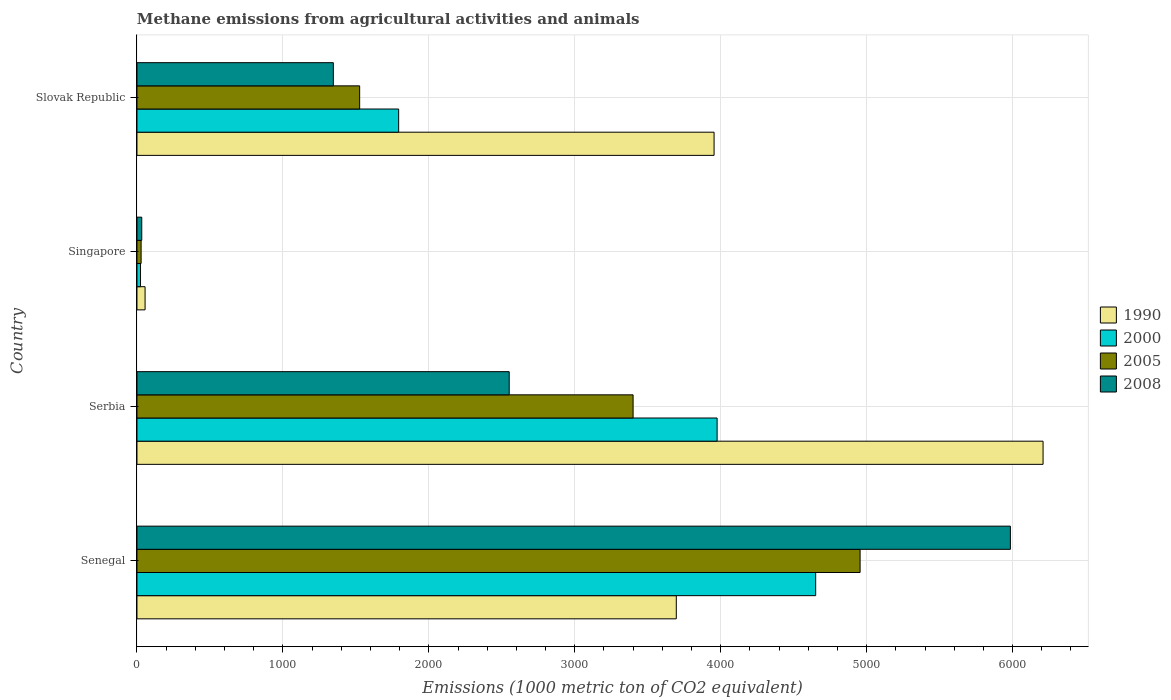How many different coloured bars are there?
Ensure brevity in your answer.  4. How many bars are there on the 3rd tick from the top?
Your answer should be compact. 4. What is the label of the 4th group of bars from the top?
Provide a short and direct response. Senegal. What is the amount of methane emitted in 2005 in Slovak Republic?
Ensure brevity in your answer.  1525.9. Across all countries, what is the maximum amount of methane emitted in 2005?
Make the answer very short. 4955.1. Across all countries, what is the minimum amount of methane emitted in 2008?
Offer a very short reply. 32.8. In which country was the amount of methane emitted in 2005 maximum?
Provide a succinct answer. Senegal. In which country was the amount of methane emitted in 1990 minimum?
Offer a terse response. Singapore. What is the total amount of methane emitted in 2005 in the graph?
Your answer should be very brief. 9909. What is the difference between the amount of methane emitted in 2005 in Senegal and that in Serbia?
Make the answer very short. 1555.5. What is the difference between the amount of methane emitted in 2008 in Serbia and the amount of methane emitted in 2005 in Slovak Republic?
Your response must be concise. 1024.8. What is the average amount of methane emitted in 2005 per country?
Provide a succinct answer. 2477.25. What is the difference between the amount of methane emitted in 1990 and amount of methane emitted in 2000 in Slovak Republic?
Provide a succinct answer. 2161.3. In how many countries, is the amount of methane emitted in 2008 greater than 2000 1000 metric ton?
Ensure brevity in your answer.  2. What is the ratio of the amount of methane emitted in 2000 in Senegal to that in Singapore?
Your response must be concise. 190.6. Is the amount of methane emitted in 2008 in Senegal less than that in Slovak Republic?
Offer a terse response. No. What is the difference between the highest and the second highest amount of methane emitted in 2000?
Offer a very short reply. 675.4. What is the difference between the highest and the lowest amount of methane emitted in 2008?
Offer a very short reply. 5952.1. In how many countries, is the amount of methane emitted in 2000 greater than the average amount of methane emitted in 2000 taken over all countries?
Your response must be concise. 2. Is it the case that in every country, the sum of the amount of methane emitted in 2000 and amount of methane emitted in 2008 is greater than the sum of amount of methane emitted in 1990 and amount of methane emitted in 2005?
Give a very brief answer. No. What does the 4th bar from the top in Senegal represents?
Offer a very short reply. 1990. What does the 3rd bar from the bottom in Singapore represents?
Provide a succinct answer. 2005. How many bars are there?
Provide a succinct answer. 16. What is the difference between two consecutive major ticks on the X-axis?
Your answer should be compact. 1000. Does the graph contain any zero values?
Offer a terse response. No. Does the graph contain grids?
Provide a succinct answer. Yes. Where does the legend appear in the graph?
Offer a terse response. Center right. How many legend labels are there?
Your response must be concise. 4. How are the legend labels stacked?
Ensure brevity in your answer.  Vertical. What is the title of the graph?
Provide a short and direct response. Methane emissions from agricultural activities and animals. What is the label or title of the X-axis?
Keep it short and to the point. Emissions (1000 metric ton of CO2 equivalent). What is the label or title of the Y-axis?
Your answer should be compact. Country. What is the Emissions (1000 metric ton of CO2 equivalent) of 1990 in Senegal?
Provide a succinct answer. 3695.6. What is the Emissions (1000 metric ton of CO2 equivalent) of 2000 in Senegal?
Provide a succinct answer. 4650.7. What is the Emissions (1000 metric ton of CO2 equivalent) in 2005 in Senegal?
Provide a succinct answer. 4955.1. What is the Emissions (1000 metric ton of CO2 equivalent) in 2008 in Senegal?
Ensure brevity in your answer.  5984.9. What is the Emissions (1000 metric ton of CO2 equivalent) in 1990 in Serbia?
Make the answer very short. 6208.8. What is the Emissions (1000 metric ton of CO2 equivalent) of 2000 in Serbia?
Give a very brief answer. 3975.3. What is the Emissions (1000 metric ton of CO2 equivalent) in 2005 in Serbia?
Offer a very short reply. 3399.6. What is the Emissions (1000 metric ton of CO2 equivalent) in 2008 in Serbia?
Your answer should be compact. 2550.7. What is the Emissions (1000 metric ton of CO2 equivalent) of 1990 in Singapore?
Offer a very short reply. 55.6. What is the Emissions (1000 metric ton of CO2 equivalent) in 2000 in Singapore?
Provide a succinct answer. 24.4. What is the Emissions (1000 metric ton of CO2 equivalent) of 2005 in Singapore?
Provide a short and direct response. 28.4. What is the Emissions (1000 metric ton of CO2 equivalent) in 2008 in Singapore?
Your answer should be very brief. 32.8. What is the Emissions (1000 metric ton of CO2 equivalent) of 1990 in Slovak Republic?
Your response must be concise. 3954.5. What is the Emissions (1000 metric ton of CO2 equivalent) of 2000 in Slovak Republic?
Provide a succinct answer. 1793.2. What is the Emissions (1000 metric ton of CO2 equivalent) in 2005 in Slovak Republic?
Provide a succinct answer. 1525.9. What is the Emissions (1000 metric ton of CO2 equivalent) in 2008 in Slovak Republic?
Offer a terse response. 1345.7. Across all countries, what is the maximum Emissions (1000 metric ton of CO2 equivalent) in 1990?
Offer a terse response. 6208.8. Across all countries, what is the maximum Emissions (1000 metric ton of CO2 equivalent) of 2000?
Provide a short and direct response. 4650.7. Across all countries, what is the maximum Emissions (1000 metric ton of CO2 equivalent) of 2005?
Offer a terse response. 4955.1. Across all countries, what is the maximum Emissions (1000 metric ton of CO2 equivalent) in 2008?
Offer a very short reply. 5984.9. Across all countries, what is the minimum Emissions (1000 metric ton of CO2 equivalent) of 1990?
Offer a very short reply. 55.6. Across all countries, what is the minimum Emissions (1000 metric ton of CO2 equivalent) in 2000?
Your answer should be very brief. 24.4. Across all countries, what is the minimum Emissions (1000 metric ton of CO2 equivalent) in 2005?
Offer a terse response. 28.4. Across all countries, what is the minimum Emissions (1000 metric ton of CO2 equivalent) in 2008?
Offer a terse response. 32.8. What is the total Emissions (1000 metric ton of CO2 equivalent) of 1990 in the graph?
Provide a short and direct response. 1.39e+04. What is the total Emissions (1000 metric ton of CO2 equivalent) in 2000 in the graph?
Provide a short and direct response. 1.04e+04. What is the total Emissions (1000 metric ton of CO2 equivalent) in 2005 in the graph?
Your answer should be compact. 9909. What is the total Emissions (1000 metric ton of CO2 equivalent) of 2008 in the graph?
Make the answer very short. 9914.1. What is the difference between the Emissions (1000 metric ton of CO2 equivalent) in 1990 in Senegal and that in Serbia?
Make the answer very short. -2513.2. What is the difference between the Emissions (1000 metric ton of CO2 equivalent) in 2000 in Senegal and that in Serbia?
Your answer should be very brief. 675.4. What is the difference between the Emissions (1000 metric ton of CO2 equivalent) in 2005 in Senegal and that in Serbia?
Offer a very short reply. 1555.5. What is the difference between the Emissions (1000 metric ton of CO2 equivalent) in 2008 in Senegal and that in Serbia?
Offer a terse response. 3434.2. What is the difference between the Emissions (1000 metric ton of CO2 equivalent) in 1990 in Senegal and that in Singapore?
Make the answer very short. 3640. What is the difference between the Emissions (1000 metric ton of CO2 equivalent) in 2000 in Senegal and that in Singapore?
Ensure brevity in your answer.  4626.3. What is the difference between the Emissions (1000 metric ton of CO2 equivalent) of 2005 in Senegal and that in Singapore?
Your answer should be very brief. 4926.7. What is the difference between the Emissions (1000 metric ton of CO2 equivalent) of 2008 in Senegal and that in Singapore?
Provide a short and direct response. 5952.1. What is the difference between the Emissions (1000 metric ton of CO2 equivalent) of 1990 in Senegal and that in Slovak Republic?
Provide a succinct answer. -258.9. What is the difference between the Emissions (1000 metric ton of CO2 equivalent) in 2000 in Senegal and that in Slovak Republic?
Your response must be concise. 2857.5. What is the difference between the Emissions (1000 metric ton of CO2 equivalent) of 2005 in Senegal and that in Slovak Republic?
Ensure brevity in your answer.  3429.2. What is the difference between the Emissions (1000 metric ton of CO2 equivalent) of 2008 in Senegal and that in Slovak Republic?
Give a very brief answer. 4639.2. What is the difference between the Emissions (1000 metric ton of CO2 equivalent) in 1990 in Serbia and that in Singapore?
Your answer should be very brief. 6153.2. What is the difference between the Emissions (1000 metric ton of CO2 equivalent) in 2000 in Serbia and that in Singapore?
Provide a succinct answer. 3950.9. What is the difference between the Emissions (1000 metric ton of CO2 equivalent) of 2005 in Serbia and that in Singapore?
Keep it short and to the point. 3371.2. What is the difference between the Emissions (1000 metric ton of CO2 equivalent) of 2008 in Serbia and that in Singapore?
Give a very brief answer. 2517.9. What is the difference between the Emissions (1000 metric ton of CO2 equivalent) of 1990 in Serbia and that in Slovak Republic?
Make the answer very short. 2254.3. What is the difference between the Emissions (1000 metric ton of CO2 equivalent) in 2000 in Serbia and that in Slovak Republic?
Your answer should be very brief. 2182.1. What is the difference between the Emissions (1000 metric ton of CO2 equivalent) in 2005 in Serbia and that in Slovak Republic?
Offer a very short reply. 1873.7. What is the difference between the Emissions (1000 metric ton of CO2 equivalent) in 2008 in Serbia and that in Slovak Republic?
Provide a succinct answer. 1205. What is the difference between the Emissions (1000 metric ton of CO2 equivalent) in 1990 in Singapore and that in Slovak Republic?
Your answer should be compact. -3898.9. What is the difference between the Emissions (1000 metric ton of CO2 equivalent) in 2000 in Singapore and that in Slovak Republic?
Ensure brevity in your answer.  -1768.8. What is the difference between the Emissions (1000 metric ton of CO2 equivalent) in 2005 in Singapore and that in Slovak Republic?
Provide a succinct answer. -1497.5. What is the difference between the Emissions (1000 metric ton of CO2 equivalent) of 2008 in Singapore and that in Slovak Republic?
Your answer should be compact. -1312.9. What is the difference between the Emissions (1000 metric ton of CO2 equivalent) in 1990 in Senegal and the Emissions (1000 metric ton of CO2 equivalent) in 2000 in Serbia?
Ensure brevity in your answer.  -279.7. What is the difference between the Emissions (1000 metric ton of CO2 equivalent) of 1990 in Senegal and the Emissions (1000 metric ton of CO2 equivalent) of 2005 in Serbia?
Your response must be concise. 296. What is the difference between the Emissions (1000 metric ton of CO2 equivalent) of 1990 in Senegal and the Emissions (1000 metric ton of CO2 equivalent) of 2008 in Serbia?
Give a very brief answer. 1144.9. What is the difference between the Emissions (1000 metric ton of CO2 equivalent) in 2000 in Senegal and the Emissions (1000 metric ton of CO2 equivalent) in 2005 in Serbia?
Give a very brief answer. 1251.1. What is the difference between the Emissions (1000 metric ton of CO2 equivalent) of 2000 in Senegal and the Emissions (1000 metric ton of CO2 equivalent) of 2008 in Serbia?
Provide a short and direct response. 2100. What is the difference between the Emissions (1000 metric ton of CO2 equivalent) in 2005 in Senegal and the Emissions (1000 metric ton of CO2 equivalent) in 2008 in Serbia?
Ensure brevity in your answer.  2404.4. What is the difference between the Emissions (1000 metric ton of CO2 equivalent) of 1990 in Senegal and the Emissions (1000 metric ton of CO2 equivalent) of 2000 in Singapore?
Give a very brief answer. 3671.2. What is the difference between the Emissions (1000 metric ton of CO2 equivalent) in 1990 in Senegal and the Emissions (1000 metric ton of CO2 equivalent) in 2005 in Singapore?
Ensure brevity in your answer.  3667.2. What is the difference between the Emissions (1000 metric ton of CO2 equivalent) of 1990 in Senegal and the Emissions (1000 metric ton of CO2 equivalent) of 2008 in Singapore?
Give a very brief answer. 3662.8. What is the difference between the Emissions (1000 metric ton of CO2 equivalent) in 2000 in Senegal and the Emissions (1000 metric ton of CO2 equivalent) in 2005 in Singapore?
Offer a very short reply. 4622.3. What is the difference between the Emissions (1000 metric ton of CO2 equivalent) in 2000 in Senegal and the Emissions (1000 metric ton of CO2 equivalent) in 2008 in Singapore?
Offer a terse response. 4617.9. What is the difference between the Emissions (1000 metric ton of CO2 equivalent) in 2005 in Senegal and the Emissions (1000 metric ton of CO2 equivalent) in 2008 in Singapore?
Offer a very short reply. 4922.3. What is the difference between the Emissions (1000 metric ton of CO2 equivalent) of 1990 in Senegal and the Emissions (1000 metric ton of CO2 equivalent) of 2000 in Slovak Republic?
Your answer should be very brief. 1902.4. What is the difference between the Emissions (1000 metric ton of CO2 equivalent) in 1990 in Senegal and the Emissions (1000 metric ton of CO2 equivalent) in 2005 in Slovak Republic?
Your answer should be very brief. 2169.7. What is the difference between the Emissions (1000 metric ton of CO2 equivalent) of 1990 in Senegal and the Emissions (1000 metric ton of CO2 equivalent) of 2008 in Slovak Republic?
Your answer should be very brief. 2349.9. What is the difference between the Emissions (1000 metric ton of CO2 equivalent) of 2000 in Senegal and the Emissions (1000 metric ton of CO2 equivalent) of 2005 in Slovak Republic?
Offer a very short reply. 3124.8. What is the difference between the Emissions (1000 metric ton of CO2 equivalent) of 2000 in Senegal and the Emissions (1000 metric ton of CO2 equivalent) of 2008 in Slovak Republic?
Provide a succinct answer. 3305. What is the difference between the Emissions (1000 metric ton of CO2 equivalent) in 2005 in Senegal and the Emissions (1000 metric ton of CO2 equivalent) in 2008 in Slovak Republic?
Your answer should be compact. 3609.4. What is the difference between the Emissions (1000 metric ton of CO2 equivalent) of 1990 in Serbia and the Emissions (1000 metric ton of CO2 equivalent) of 2000 in Singapore?
Your response must be concise. 6184.4. What is the difference between the Emissions (1000 metric ton of CO2 equivalent) of 1990 in Serbia and the Emissions (1000 metric ton of CO2 equivalent) of 2005 in Singapore?
Offer a very short reply. 6180.4. What is the difference between the Emissions (1000 metric ton of CO2 equivalent) of 1990 in Serbia and the Emissions (1000 metric ton of CO2 equivalent) of 2008 in Singapore?
Your response must be concise. 6176. What is the difference between the Emissions (1000 metric ton of CO2 equivalent) of 2000 in Serbia and the Emissions (1000 metric ton of CO2 equivalent) of 2005 in Singapore?
Make the answer very short. 3946.9. What is the difference between the Emissions (1000 metric ton of CO2 equivalent) in 2000 in Serbia and the Emissions (1000 metric ton of CO2 equivalent) in 2008 in Singapore?
Make the answer very short. 3942.5. What is the difference between the Emissions (1000 metric ton of CO2 equivalent) of 2005 in Serbia and the Emissions (1000 metric ton of CO2 equivalent) of 2008 in Singapore?
Keep it short and to the point. 3366.8. What is the difference between the Emissions (1000 metric ton of CO2 equivalent) in 1990 in Serbia and the Emissions (1000 metric ton of CO2 equivalent) in 2000 in Slovak Republic?
Give a very brief answer. 4415.6. What is the difference between the Emissions (1000 metric ton of CO2 equivalent) in 1990 in Serbia and the Emissions (1000 metric ton of CO2 equivalent) in 2005 in Slovak Republic?
Provide a short and direct response. 4682.9. What is the difference between the Emissions (1000 metric ton of CO2 equivalent) of 1990 in Serbia and the Emissions (1000 metric ton of CO2 equivalent) of 2008 in Slovak Republic?
Your answer should be compact. 4863.1. What is the difference between the Emissions (1000 metric ton of CO2 equivalent) of 2000 in Serbia and the Emissions (1000 metric ton of CO2 equivalent) of 2005 in Slovak Republic?
Make the answer very short. 2449.4. What is the difference between the Emissions (1000 metric ton of CO2 equivalent) in 2000 in Serbia and the Emissions (1000 metric ton of CO2 equivalent) in 2008 in Slovak Republic?
Keep it short and to the point. 2629.6. What is the difference between the Emissions (1000 metric ton of CO2 equivalent) of 2005 in Serbia and the Emissions (1000 metric ton of CO2 equivalent) of 2008 in Slovak Republic?
Ensure brevity in your answer.  2053.9. What is the difference between the Emissions (1000 metric ton of CO2 equivalent) of 1990 in Singapore and the Emissions (1000 metric ton of CO2 equivalent) of 2000 in Slovak Republic?
Your response must be concise. -1737.6. What is the difference between the Emissions (1000 metric ton of CO2 equivalent) of 1990 in Singapore and the Emissions (1000 metric ton of CO2 equivalent) of 2005 in Slovak Republic?
Provide a succinct answer. -1470.3. What is the difference between the Emissions (1000 metric ton of CO2 equivalent) in 1990 in Singapore and the Emissions (1000 metric ton of CO2 equivalent) in 2008 in Slovak Republic?
Your response must be concise. -1290.1. What is the difference between the Emissions (1000 metric ton of CO2 equivalent) in 2000 in Singapore and the Emissions (1000 metric ton of CO2 equivalent) in 2005 in Slovak Republic?
Offer a very short reply. -1501.5. What is the difference between the Emissions (1000 metric ton of CO2 equivalent) in 2000 in Singapore and the Emissions (1000 metric ton of CO2 equivalent) in 2008 in Slovak Republic?
Ensure brevity in your answer.  -1321.3. What is the difference between the Emissions (1000 metric ton of CO2 equivalent) in 2005 in Singapore and the Emissions (1000 metric ton of CO2 equivalent) in 2008 in Slovak Republic?
Provide a short and direct response. -1317.3. What is the average Emissions (1000 metric ton of CO2 equivalent) of 1990 per country?
Offer a very short reply. 3478.62. What is the average Emissions (1000 metric ton of CO2 equivalent) in 2000 per country?
Your answer should be very brief. 2610.9. What is the average Emissions (1000 metric ton of CO2 equivalent) of 2005 per country?
Give a very brief answer. 2477.25. What is the average Emissions (1000 metric ton of CO2 equivalent) in 2008 per country?
Your answer should be compact. 2478.53. What is the difference between the Emissions (1000 metric ton of CO2 equivalent) in 1990 and Emissions (1000 metric ton of CO2 equivalent) in 2000 in Senegal?
Ensure brevity in your answer.  -955.1. What is the difference between the Emissions (1000 metric ton of CO2 equivalent) in 1990 and Emissions (1000 metric ton of CO2 equivalent) in 2005 in Senegal?
Provide a succinct answer. -1259.5. What is the difference between the Emissions (1000 metric ton of CO2 equivalent) in 1990 and Emissions (1000 metric ton of CO2 equivalent) in 2008 in Senegal?
Provide a succinct answer. -2289.3. What is the difference between the Emissions (1000 metric ton of CO2 equivalent) of 2000 and Emissions (1000 metric ton of CO2 equivalent) of 2005 in Senegal?
Your answer should be compact. -304.4. What is the difference between the Emissions (1000 metric ton of CO2 equivalent) of 2000 and Emissions (1000 metric ton of CO2 equivalent) of 2008 in Senegal?
Your response must be concise. -1334.2. What is the difference between the Emissions (1000 metric ton of CO2 equivalent) of 2005 and Emissions (1000 metric ton of CO2 equivalent) of 2008 in Senegal?
Ensure brevity in your answer.  -1029.8. What is the difference between the Emissions (1000 metric ton of CO2 equivalent) in 1990 and Emissions (1000 metric ton of CO2 equivalent) in 2000 in Serbia?
Offer a very short reply. 2233.5. What is the difference between the Emissions (1000 metric ton of CO2 equivalent) in 1990 and Emissions (1000 metric ton of CO2 equivalent) in 2005 in Serbia?
Make the answer very short. 2809.2. What is the difference between the Emissions (1000 metric ton of CO2 equivalent) of 1990 and Emissions (1000 metric ton of CO2 equivalent) of 2008 in Serbia?
Provide a short and direct response. 3658.1. What is the difference between the Emissions (1000 metric ton of CO2 equivalent) in 2000 and Emissions (1000 metric ton of CO2 equivalent) in 2005 in Serbia?
Give a very brief answer. 575.7. What is the difference between the Emissions (1000 metric ton of CO2 equivalent) of 2000 and Emissions (1000 metric ton of CO2 equivalent) of 2008 in Serbia?
Ensure brevity in your answer.  1424.6. What is the difference between the Emissions (1000 metric ton of CO2 equivalent) in 2005 and Emissions (1000 metric ton of CO2 equivalent) in 2008 in Serbia?
Ensure brevity in your answer.  848.9. What is the difference between the Emissions (1000 metric ton of CO2 equivalent) of 1990 and Emissions (1000 metric ton of CO2 equivalent) of 2000 in Singapore?
Ensure brevity in your answer.  31.2. What is the difference between the Emissions (1000 metric ton of CO2 equivalent) in 1990 and Emissions (1000 metric ton of CO2 equivalent) in 2005 in Singapore?
Your answer should be very brief. 27.2. What is the difference between the Emissions (1000 metric ton of CO2 equivalent) of 1990 and Emissions (1000 metric ton of CO2 equivalent) of 2008 in Singapore?
Give a very brief answer. 22.8. What is the difference between the Emissions (1000 metric ton of CO2 equivalent) of 2000 and Emissions (1000 metric ton of CO2 equivalent) of 2005 in Singapore?
Give a very brief answer. -4. What is the difference between the Emissions (1000 metric ton of CO2 equivalent) of 2005 and Emissions (1000 metric ton of CO2 equivalent) of 2008 in Singapore?
Offer a very short reply. -4.4. What is the difference between the Emissions (1000 metric ton of CO2 equivalent) in 1990 and Emissions (1000 metric ton of CO2 equivalent) in 2000 in Slovak Republic?
Keep it short and to the point. 2161.3. What is the difference between the Emissions (1000 metric ton of CO2 equivalent) of 1990 and Emissions (1000 metric ton of CO2 equivalent) of 2005 in Slovak Republic?
Make the answer very short. 2428.6. What is the difference between the Emissions (1000 metric ton of CO2 equivalent) in 1990 and Emissions (1000 metric ton of CO2 equivalent) in 2008 in Slovak Republic?
Offer a very short reply. 2608.8. What is the difference between the Emissions (1000 metric ton of CO2 equivalent) in 2000 and Emissions (1000 metric ton of CO2 equivalent) in 2005 in Slovak Republic?
Keep it short and to the point. 267.3. What is the difference between the Emissions (1000 metric ton of CO2 equivalent) in 2000 and Emissions (1000 metric ton of CO2 equivalent) in 2008 in Slovak Republic?
Keep it short and to the point. 447.5. What is the difference between the Emissions (1000 metric ton of CO2 equivalent) in 2005 and Emissions (1000 metric ton of CO2 equivalent) in 2008 in Slovak Republic?
Provide a succinct answer. 180.2. What is the ratio of the Emissions (1000 metric ton of CO2 equivalent) of 1990 in Senegal to that in Serbia?
Give a very brief answer. 0.6. What is the ratio of the Emissions (1000 metric ton of CO2 equivalent) of 2000 in Senegal to that in Serbia?
Offer a terse response. 1.17. What is the ratio of the Emissions (1000 metric ton of CO2 equivalent) of 2005 in Senegal to that in Serbia?
Make the answer very short. 1.46. What is the ratio of the Emissions (1000 metric ton of CO2 equivalent) of 2008 in Senegal to that in Serbia?
Your answer should be very brief. 2.35. What is the ratio of the Emissions (1000 metric ton of CO2 equivalent) in 1990 in Senegal to that in Singapore?
Give a very brief answer. 66.47. What is the ratio of the Emissions (1000 metric ton of CO2 equivalent) of 2000 in Senegal to that in Singapore?
Make the answer very short. 190.6. What is the ratio of the Emissions (1000 metric ton of CO2 equivalent) of 2005 in Senegal to that in Singapore?
Your answer should be compact. 174.48. What is the ratio of the Emissions (1000 metric ton of CO2 equivalent) of 2008 in Senegal to that in Singapore?
Make the answer very short. 182.47. What is the ratio of the Emissions (1000 metric ton of CO2 equivalent) in 1990 in Senegal to that in Slovak Republic?
Keep it short and to the point. 0.93. What is the ratio of the Emissions (1000 metric ton of CO2 equivalent) of 2000 in Senegal to that in Slovak Republic?
Give a very brief answer. 2.59. What is the ratio of the Emissions (1000 metric ton of CO2 equivalent) in 2005 in Senegal to that in Slovak Republic?
Offer a very short reply. 3.25. What is the ratio of the Emissions (1000 metric ton of CO2 equivalent) of 2008 in Senegal to that in Slovak Republic?
Your answer should be very brief. 4.45. What is the ratio of the Emissions (1000 metric ton of CO2 equivalent) in 1990 in Serbia to that in Singapore?
Give a very brief answer. 111.67. What is the ratio of the Emissions (1000 metric ton of CO2 equivalent) of 2000 in Serbia to that in Singapore?
Keep it short and to the point. 162.92. What is the ratio of the Emissions (1000 metric ton of CO2 equivalent) in 2005 in Serbia to that in Singapore?
Provide a short and direct response. 119.7. What is the ratio of the Emissions (1000 metric ton of CO2 equivalent) of 2008 in Serbia to that in Singapore?
Give a very brief answer. 77.77. What is the ratio of the Emissions (1000 metric ton of CO2 equivalent) in 1990 in Serbia to that in Slovak Republic?
Offer a very short reply. 1.57. What is the ratio of the Emissions (1000 metric ton of CO2 equivalent) of 2000 in Serbia to that in Slovak Republic?
Offer a terse response. 2.22. What is the ratio of the Emissions (1000 metric ton of CO2 equivalent) of 2005 in Serbia to that in Slovak Republic?
Keep it short and to the point. 2.23. What is the ratio of the Emissions (1000 metric ton of CO2 equivalent) in 2008 in Serbia to that in Slovak Republic?
Offer a very short reply. 1.9. What is the ratio of the Emissions (1000 metric ton of CO2 equivalent) in 1990 in Singapore to that in Slovak Republic?
Provide a succinct answer. 0.01. What is the ratio of the Emissions (1000 metric ton of CO2 equivalent) of 2000 in Singapore to that in Slovak Republic?
Provide a succinct answer. 0.01. What is the ratio of the Emissions (1000 metric ton of CO2 equivalent) of 2005 in Singapore to that in Slovak Republic?
Ensure brevity in your answer.  0.02. What is the ratio of the Emissions (1000 metric ton of CO2 equivalent) in 2008 in Singapore to that in Slovak Republic?
Offer a terse response. 0.02. What is the difference between the highest and the second highest Emissions (1000 metric ton of CO2 equivalent) in 1990?
Make the answer very short. 2254.3. What is the difference between the highest and the second highest Emissions (1000 metric ton of CO2 equivalent) of 2000?
Offer a very short reply. 675.4. What is the difference between the highest and the second highest Emissions (1000 metric ton of CO2 equivalent) of 2005?
Ensure brevity in your answer.  1555.5. What is the difference between the highest and the second highest Emissions (1000 metric ton of CO2 equivalent) of 2008?
Your answer should be compact. 3434.2. What is the difference between the highest and the lowest Emissions (1000 metric ton of CO2 equivalent) in 1990?
Give a very brief answer. 6153.2. What is the difference between the highest and the lowest Emissions (1000 metric ton of CO2 equivalent) of 2000?
Give a very brief answer. 4626.3. What is the difference between the highest and the lowest Emissions (1000 metric ton of CO2 equivalent) in 2005?
Offer a very short reply. 4926.7. What is the difference between the highest and the lowest Emissions (1000 metric ton of CO2 equivalent) of 2008?
Provide a succinct answer. 5952.1. 